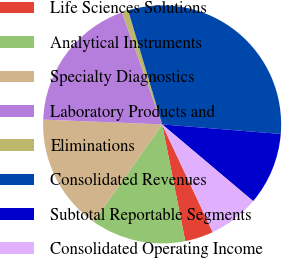Convert chart. <chart><loc_0><loc_0><loc_500><loc_500><pie_chart><fcel>Life Sciences Solutions<fcel>Analytical Instruments<fcel>Specialty Diagnostics<fcel>Laboratory Products and<fcel>Eliminations<fcel>Consolidated Revenues<fcel>Subtotal Reportable Segments<fcel>Consolidated Operating Income<nl><fcel>3.87%<fcel>12.88%<fcel>15.88%<fcel>18.88%<fcel>0.87%<fcel>30.89%<fcel>9.87%<fcel>6.87%<nl></chart> 